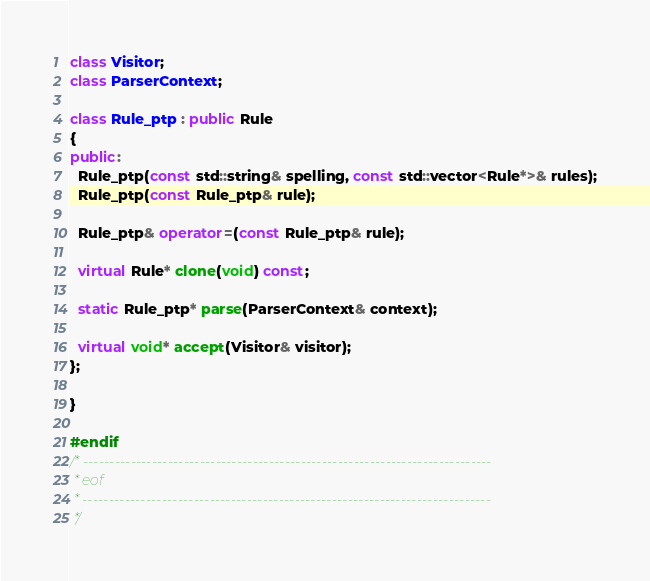<code> <loc_0><loc_0><loc_500><loc_500><_C++_>class Visitor;
class ParserContext;

class Rule_ptp : public Rule
{
public:
  Rule_ptp(const std::string& spelling, const std::vector<Rule*>& rules);
  Rule_ptp(const Rule_ptp& rule);

  Rule_ptp& operator=(const Rule_ptp& rule);

  virtual Rule* clone(void) const;

  static Rule_ptp* parse(ParserContext& context);

  virtual void* accept(Visitor& visitor);
};

}

#endif
/* -----------------------------------------------------------------------------
 * eof
 * -----------------------------------------------------------------------------
 */
</code> 